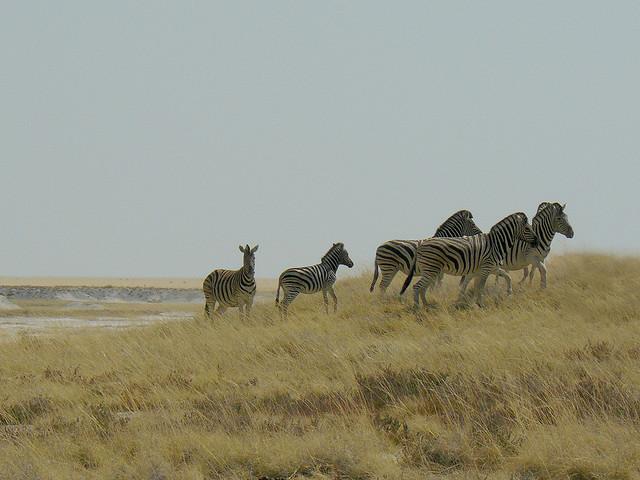Are these animals walking on a hill?
Answer briefly. Yes. How many zebra?
Give a very brief answer. 5. How many animals?
Be succinct. 5. Is this a herd animal?
Give a very brief answer. Yes. 